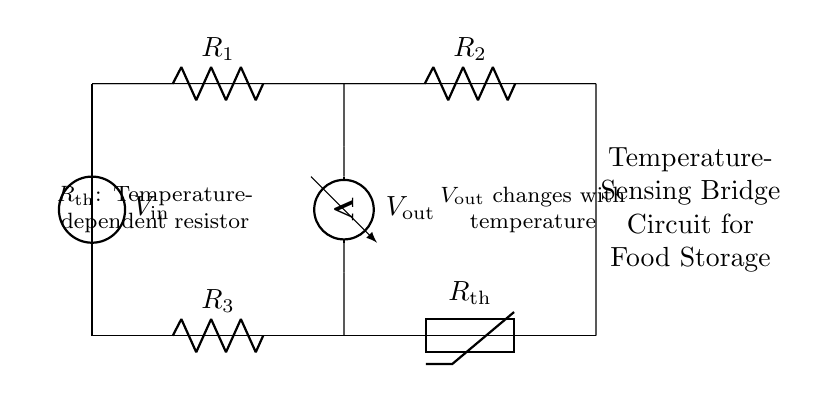What does V in this circuit represent? V represents the input voltage applied across the bridge circuit. It indicates the electrical potential difference between its terminals.
Answer: Input voltage What are R1 and R2 in the circuit? R1 and R2 are resistors that form part of the bridge configuration. They are used to balance the bridge and affect the output voltage based on changes in the thermistor resistance.
Answer: Resistors How is the output voltage affected by temperature? The output voltage changes with temperature as the thermistor (Rth) varies its resistance based on the temperature, altering the balance of the bridge and consequently the voltage measured by the voltmeter.
Answer: Changes with temperature What is the role of the thermistor in this circuit? The thermistor serves as a temperature-dependent resistor that changes its resistance with temperature variations, thus influencing the output voltage of the bridge circuit directly related to temperature readings.
Answer: Temperature-dependent resistor What is the purpose of the bridge circuit? The bridge circuit is designed to sense temperature variations and provide an output voltage that reflects those changes, which can be used for monitoring food storage conditions.
Answer: Sensing temperature 